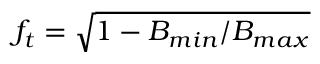Convert formula to latex. <formula><loc_0><loc_0><loc_500><loc_500>f _ { t } = \sqrt { 1 - B _ { \min } / B _ { \max } }</formula> 